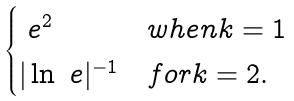<formula> <loc_0><loc_0><loc_500><loc_500>\begin{cases} \ e ^ { 2 } & w h e n k = 1 \\ | \ln \ e | ^ { - 1 } & f o r k = 2 . \end{cases}</formula> 